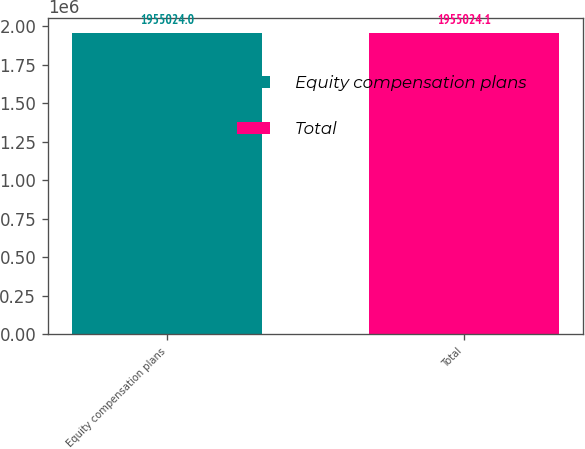Convert chart to OTSL. <chart><loc_0><loc_0><loc_500><loc_500><bar_chart><fcel>Equity compensation plans<fcel>Total<nl><fcel>1.95502e+06<fcel>1.95502e+06<nl></chart> 